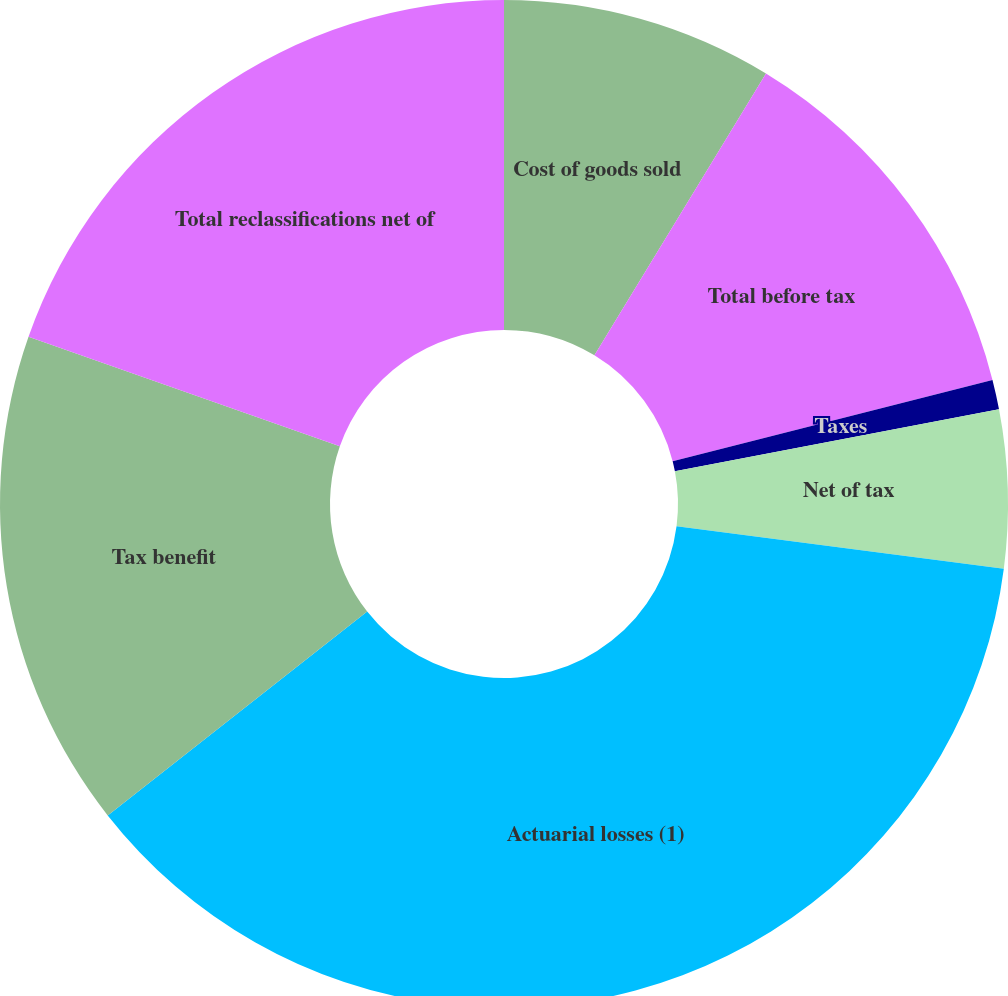<chart> <loc_0><loc_0><loc_500><loc_500><pie_chart><fcel>Cost of goods sold<fcel>Total before tax<fcel>Taxes<fcel>Net of tax<fcel>Actuarial losses (1)<fcel>Tax benefit<fcel>Total reclassifications net of<nl><fcel>8.7%<fcel>12.34%<fcel>0.95%<fcel>5.06%<fcel>37.35%<fcel>15.98%<fcel>19.62%<nl></chart> 